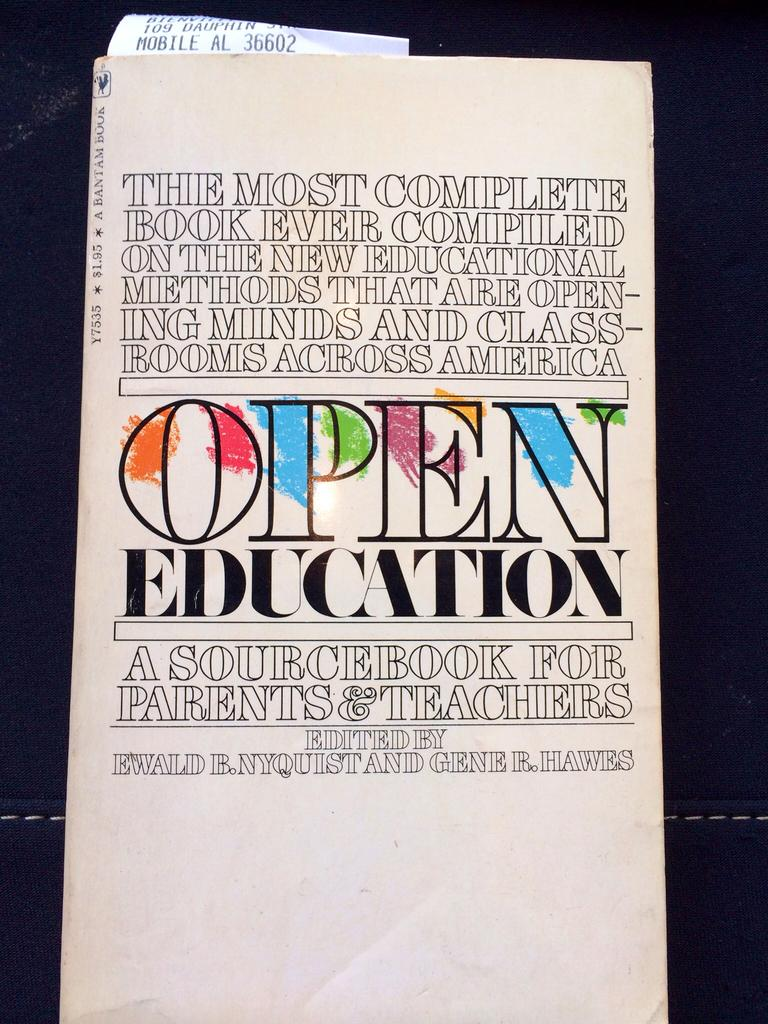<image>
Summarize the visual content of the image. A book titled Open Education has a white cover. 